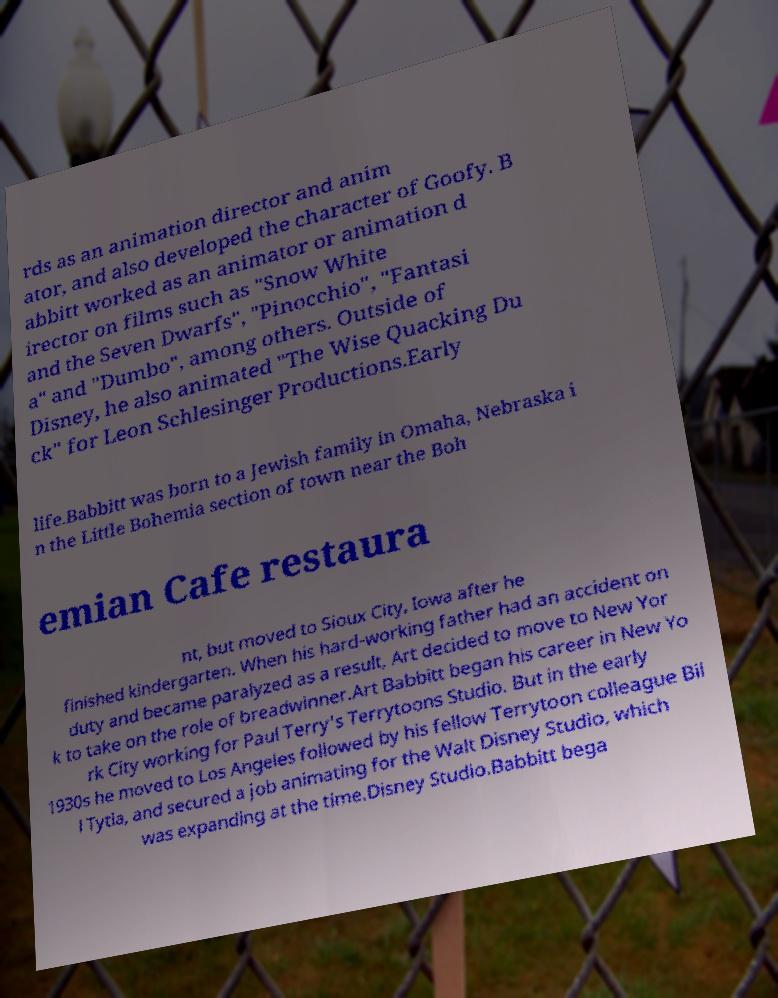I need the written content from this picture converted into text. Can you do that? rds as an animation director and anim ator, and also developed the character of Goofy. B abbitt worked as an animator or animation d irector on films such as "Snow White and the Seven Dwarfs", "Pinocchio", "Fantasi a" and "Dumbo", among others. Outside of Disney, he also animated "The Wise Quacking Du ck" for Leon Schlesinger Productions.Early life.Babbitt was born to a Jewish family in Omaha, Nebraska i n the Little Bohemia section of town near the Boh emian Cafe restaura nt, but moved to Sioux City, Iowa after he finished kindergarten. When his hard-working father had an accident on duty and became paralyzed as a result, Art decided to move to New Yor k to take on the role of breadwinner.Art Babbitt began his career in New Yo rk City working for Paul Terry's Terrytoons Studio. But in the early 1930s he moved to Los Angeles followed by his fellow Terrytoon colleague Bil l Tytla, and secured a job animating for the Walt Disney Studio, which was expanding at the time.Disney Studio.Babbitt bega 